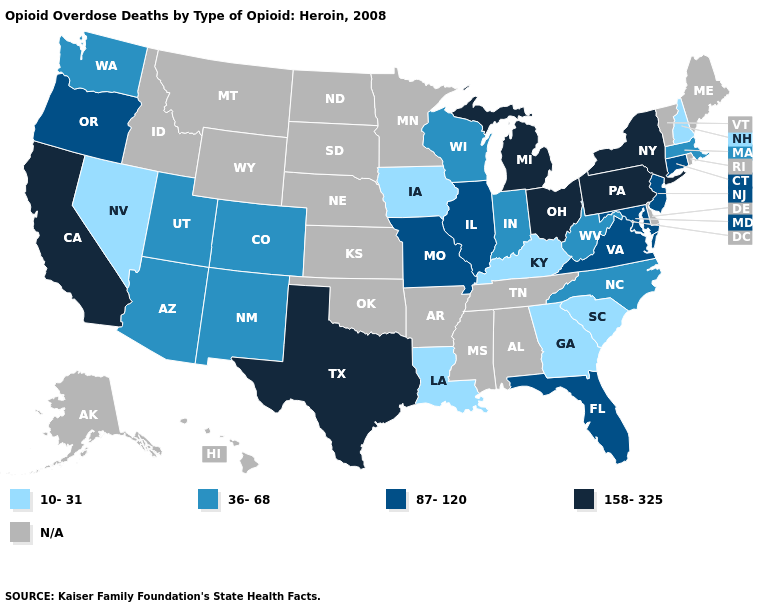What is the value of Vermont?
Be succinct. N/A. What is the lowest value in states that border Oregon?
Answer briefly. 10-31. Does Connecticut have the lowest value in the Northeast?
Write a very short answer. No. Which states have the lowest value in the USA?
Keep it brief. Georgia, Iowa, Kentucky, Louisiana, Nevada, New Hampshire, South Carolina. How many symbols are there in the legend?
Keep it brief. 5. Does the first symbol in the legend represent the smallest category?
Give a very brief answer. Yes. What is the lowest value in states that border Massachusetts?
Be succinct. 10-31. What is the value of Kentucky?
Short answer required. 10-31. Name the states that have a value in the range 87-120?
Give a very brief answer. Connecticut, Florida, Illinois, Maryland, Missouri, New Jersey, Oregon, Virginia. Among the states that border Utah , does New Mexico have the highest value?
Keep it brief. Yes. Which states have the highest value in the USA?
Short answer required. California, Michigan, New York, Ohio, Pennsylvania, Texas. What is the value of Arizona?
Keep it brief. 36-68. Name the states that have a value in the range 36-68?
Short answer required. Arizona, Colorado, Indiana, Massachusetts, New Mexico, North Carolina, Utah, Washington, West Virginia, Wisconsin. What is the value of North Carolina?
Answer briefly. 36-68. 